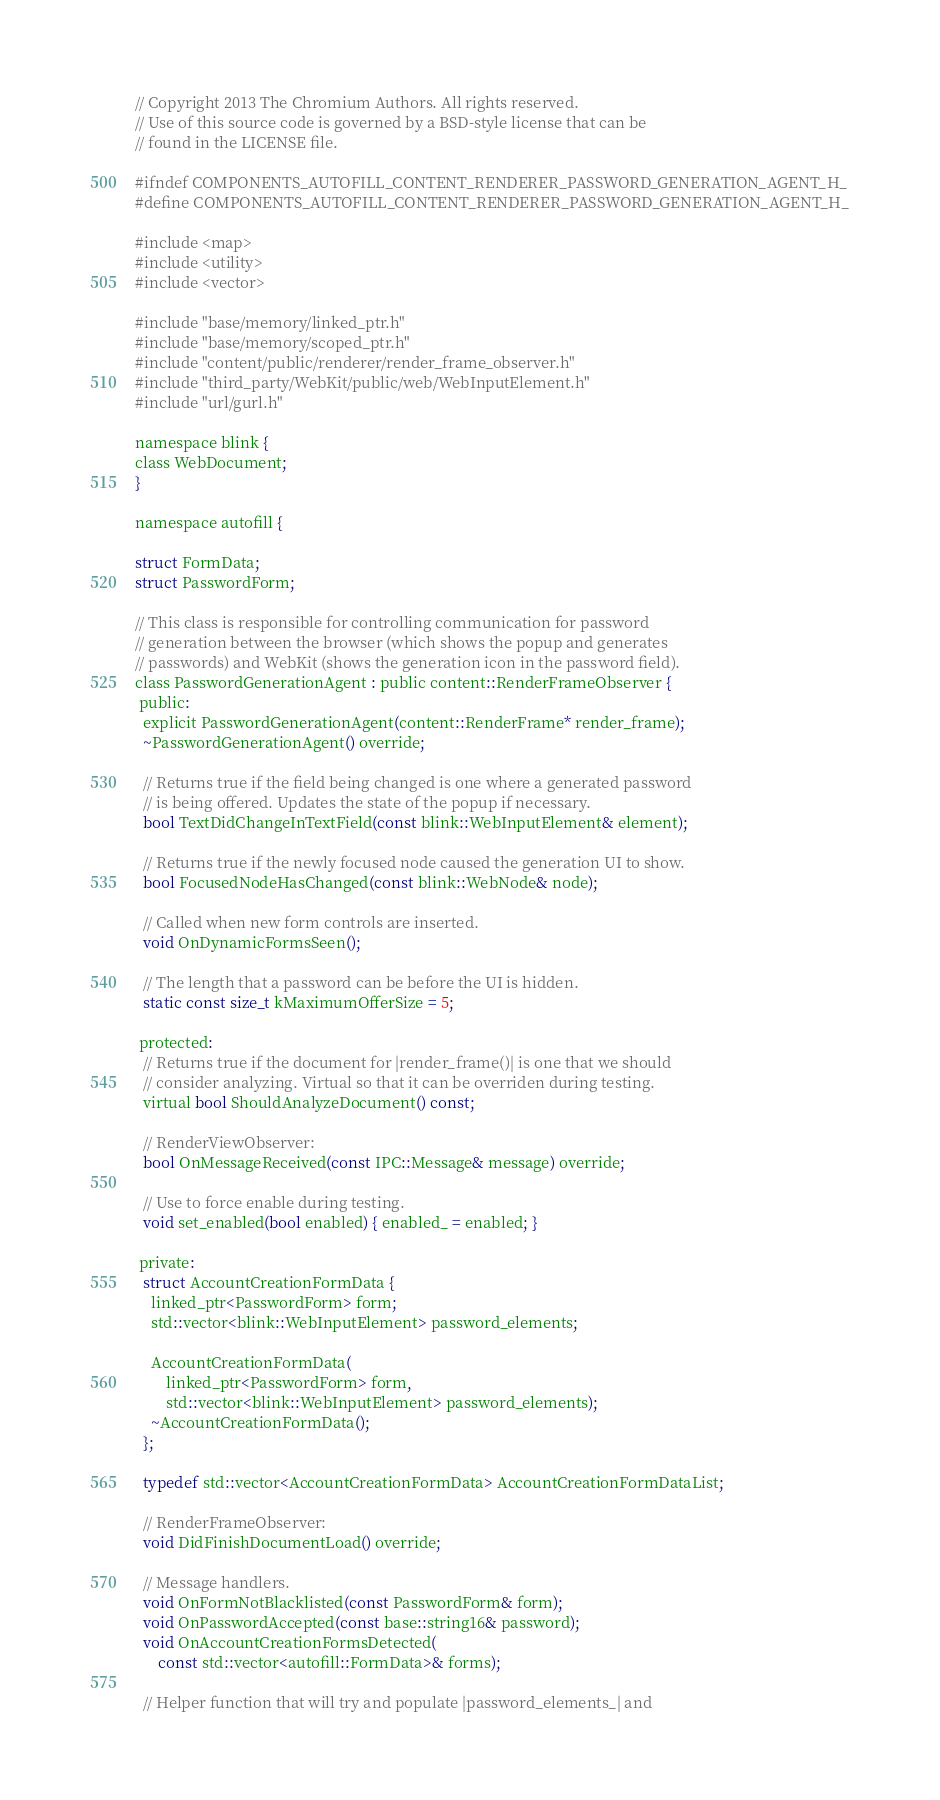Convert code to text. <code><loc_0><loc_0><loc_500><loc_500><_C_>// Copyright 2013 The Chromium Authors. All rights reserved.
// Use of this source code is governed by a BSD-style license that can be
// found in the LICENSE file.

#ifndef COMPONENTS_AUTOFILL_CONTENT_RENDERER_PASSWORD_GENERATION_AGENT_H_
#define COMPONENTS_AUTOFILL_CONTENT_RENDERER_PASSWORD_GENERATION_AGENT_H_

#include <map>
#include <utility>
#include <vector>

#include "base/memory/linked_ptr.h"
#include "base/memory/scoped_ptr.h"
#include "content/public/renderer/render_frame_observer.h"
#include "third_party/WebKit/public/web/WebInputElement.h"
#include "url/gurl.h"

namespace blink {
class WebDocument;
}

namespace autofill {

struct FormData;
struct PasswordForm;

// This class is responsible for controlling communication for password
// generation between the browser (which shows the popup and generates
// passwords) and WebKit (shows the generation icon in the password field).
class PasswordGenerationAgent : public content::RenderFrameObserver {
 public:
  explicit PasswordGenerationAgent(content::RenderFrame* render_frame);
  ~PasswordGenerationAgent() override;

  // Returns true if the field being changed is one where a generated password
  // is being offered. Updates the state of the popup if necessary.
  bool TextDidChangeInTextField(const blink::WebInputElement& element);

  // Returns true if the newly focused node caused the generation UI to show.
  bool FocusedNodeHasChanged(const blink::WebNode& node);

  // Called when new form controls are inserted.
  void OnDynamicFormsSeen();

  // The length that a password can be before the UI is hidden.
  static const size_t kMaximumOfferSize = 5;

 protected:
  // Returns true if the document for |render_frame()| is one that we should
  // consider analyzing. Virtual so that it can be overriden during testing.
  virtual bool ShouldAnalyzeDocument() const;

  // RenderViewObserver:
  bool OnMessageReceived(const IPC::Message& message) override;

  // Use to force enable during testing.
  void set_enabled(bool enabled) { enabled_ = enabled; }

 private:
  struct AccountCreationFormData {
    linked_ptr<PasswordForm> form;
    std::vector<blink::WebInputElement> password_elements;

    AccountCreationFormData(
        linked_ptr<PasswordForm> form,
        std::vector<blink::WebInputElement> password_elements);
    ~AccountCreationFormData();
  };

  typedef std::vector<AccountCreationFormData> AccountCreationFormDataList;

  // RenderFrameObserver:
  void DidFinishDocumentLoad() override;

  // Message handlers.
  void OnFormNotBlacklisted(const PasswordForm& form);
  void OnPasswordAccepted(const base::string16& password);
  void OnAccountCreationFormsDetected(
      const std::vector<autofill::FormData>& forms);

  // Helper function that will try and populate |password_elements_| and</code> 